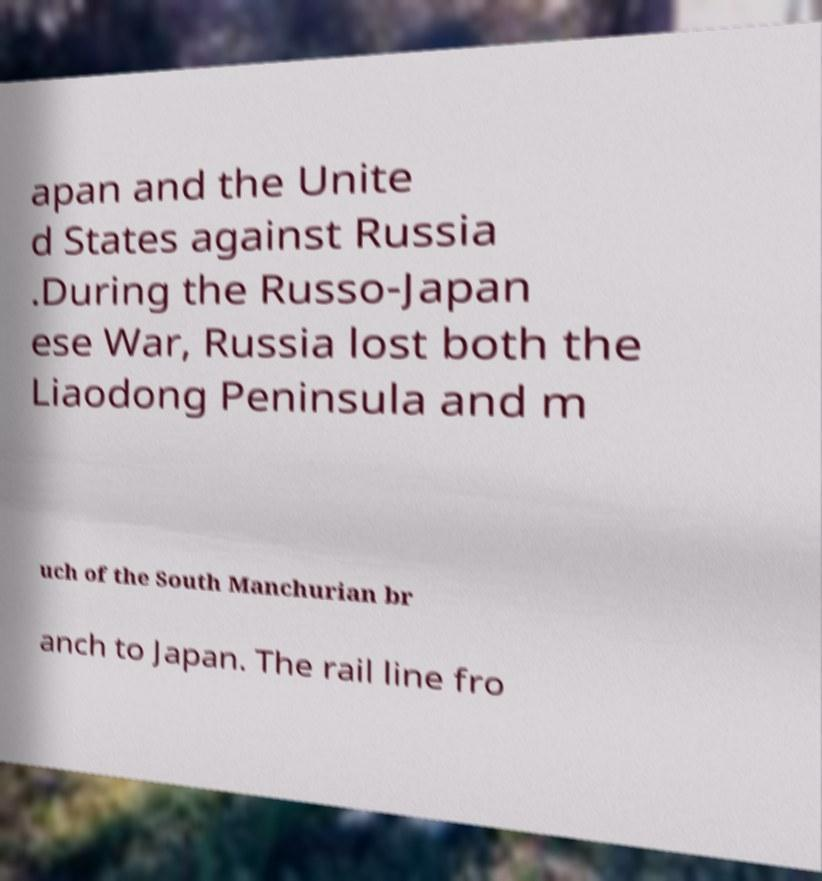Could you assist in decoding the text presented in this image and type it out clearly? apan and the Unite d States against Russia .During the Russo-Japan ese War, Russia lost both the Liaodong Peninsula and m uch of the South Manchurian br anch to Japan. The rail line fro 